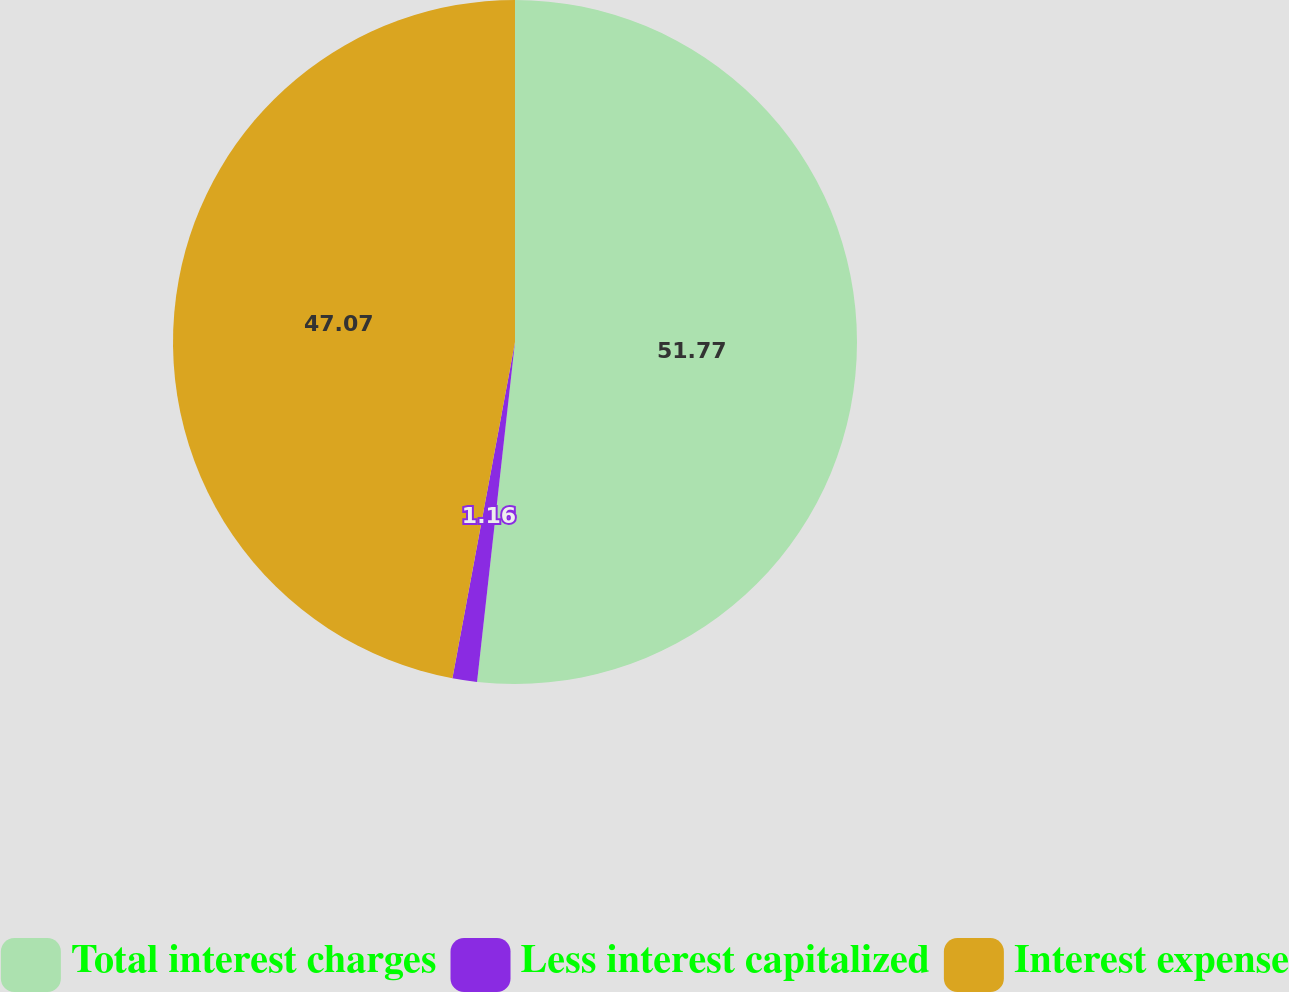Convert chart. <chart><loc_0><loc_0><loc_500><loc_500><pie_chart><fcel>Total interest charges<fcel>Less interest capitalized<fcel>Interest expense<nl><fcel>51.77%<fcel>1.16%<fcel>47.07%<nl></chart> 